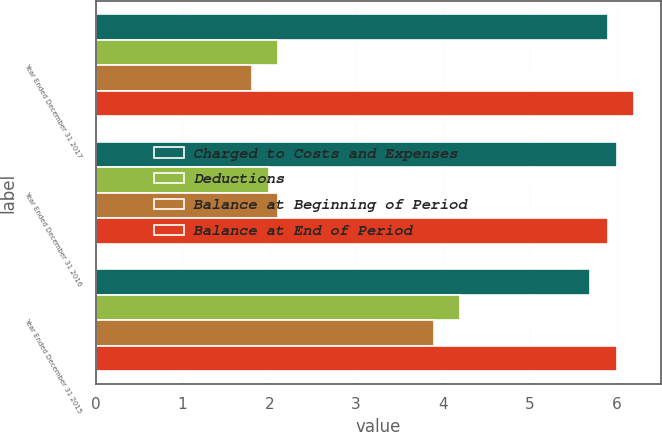Convert chart to OTSL. <chart><loc_0><loc_0><loc_500><loc_500><stacked_bar_chart><ecel><fcel>Year Ended December 31 2017<fcel>Year Ended December 31 2016<fcel>Year Ended December 31 2015<nl><fcel>Charged to Costs and Expenses<fcel>5.9<fcel>6<fcel>5.7<nl><fcel>Deductions<fcel>2.1<fcel>2<fcel>4.2<nl><fcel>Balance at Beginning of Period<fcel>1.8<fcel>2.1<fcel>3.9<nl><fcel>Balance at End of Period<fcel>6.2<fcel>5.9<fcel>6<nl></chart> 